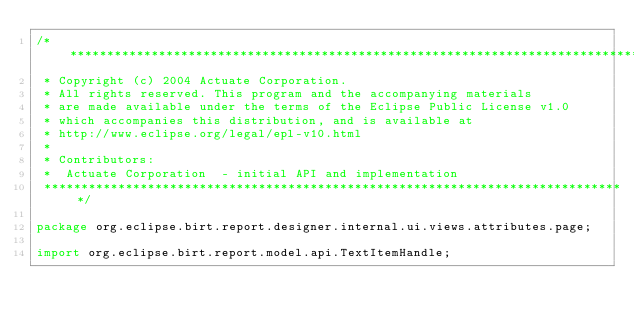<code> <loc_0><loc_0><loc_500><loc_500><_Java_>/*******************************************************************************
 * Copyright (c) 2004 Actuate Corporation.
 * All rights reserved. This program and the accompanying materials
 * are made available under the terms of the Eclipse Public License v1.0
 * which accompanies this distribution, and is available at
 * http://www.eclipse.org/legal/epl-v10.html
 *
 * Contributors:
 *  Actuate Corporation  - initial API and implementation
 *******************************************************************************/

package org.eclipse.birt.report.designer.internal.ui.views.attributes.page;

import org.eclipse.birt.report.model.api.TextItemHandle;</code> 